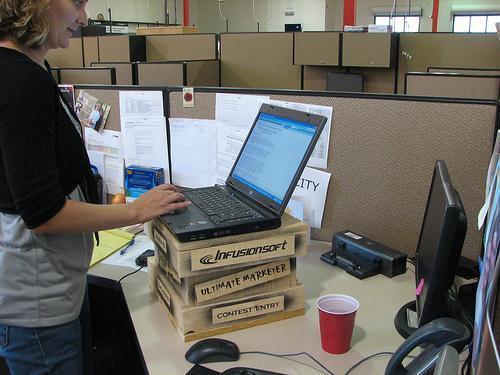How many screens?
Give a very brief answer. 2. 